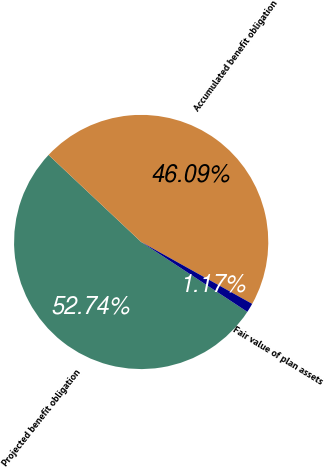Convert chart to OTSL. <chart><loc_0><loc_0><loc_500><loc_500><pie_chart><fcel>Projected benefit obligation<fcel>Accumulated benefit obligation<fcel>Fair value of plan assets<nl><fcel>52.74%<fcel>46.09%<fcel>1.17%<nl></chart> 